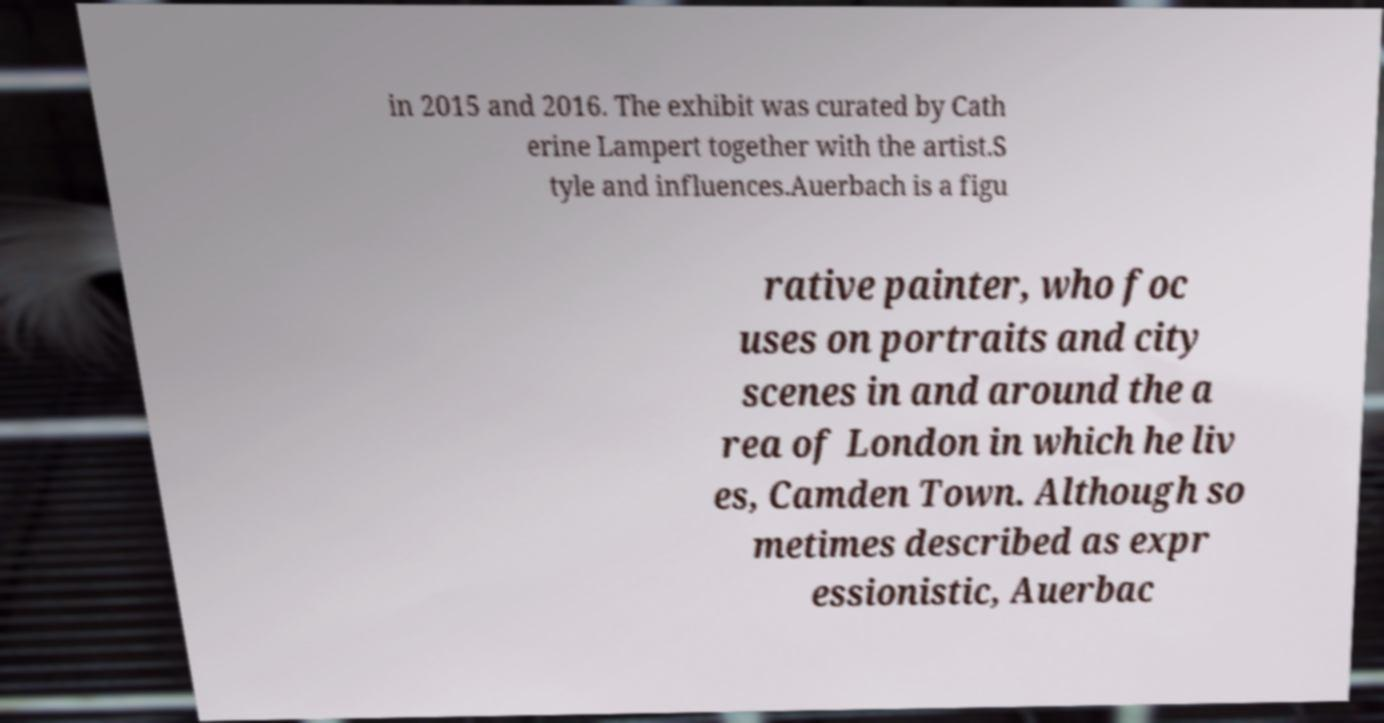Can you read and provide the text displayed in the image?This photo seems to have some interesting text. Can you extract and type it out for me? in 2015 and 2016. The exhibit was curated by Cath erine Lampert together with the artist.S tyle and influences.Auerbach is a figu rative painter, who foc uses on portraits and city scenes in and around the a rea of London in which he liv es, Camden Town. Although so metimes described as expr essionistic, Auerbac 